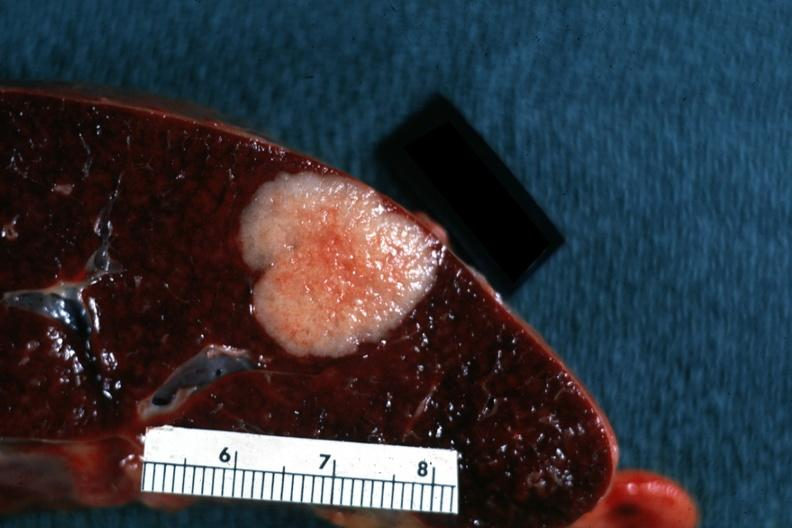s leiomyosarcoma present?
Answer the question using a single word or phrase. No 